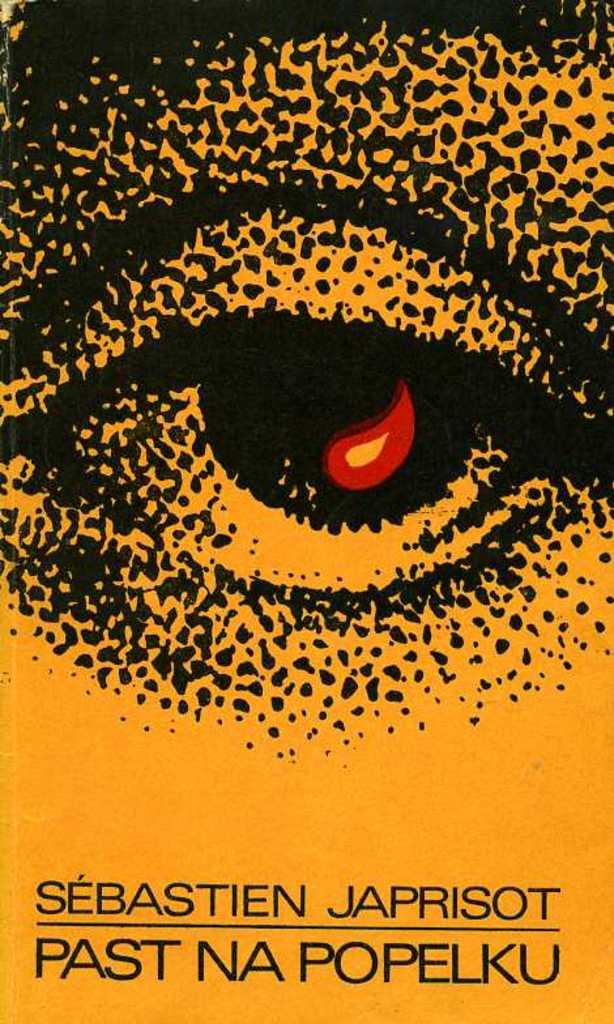<image>
Summarize the visual content of the image. The cover of the book past Na Popelku by sebastien japrisot. 